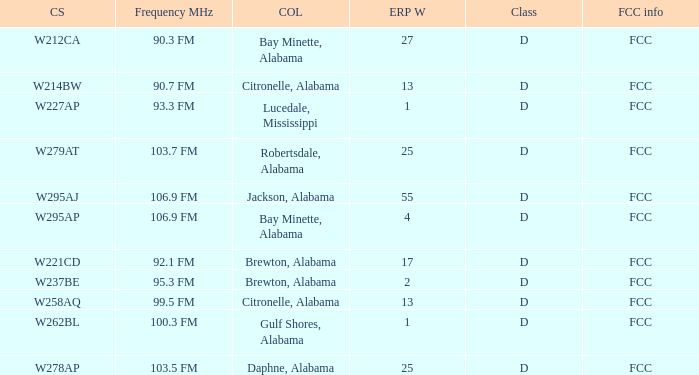What is the frequency in mhz for an erp of 55 w? 106.9 FM. 